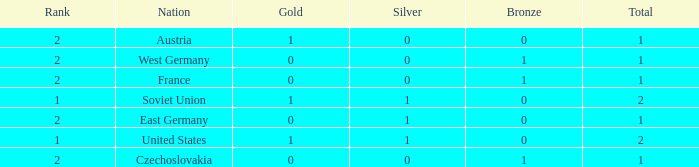What is the total number of bronze medals of West Germany, which is ranked 2 and has less than 1 total medals? 0.0. 